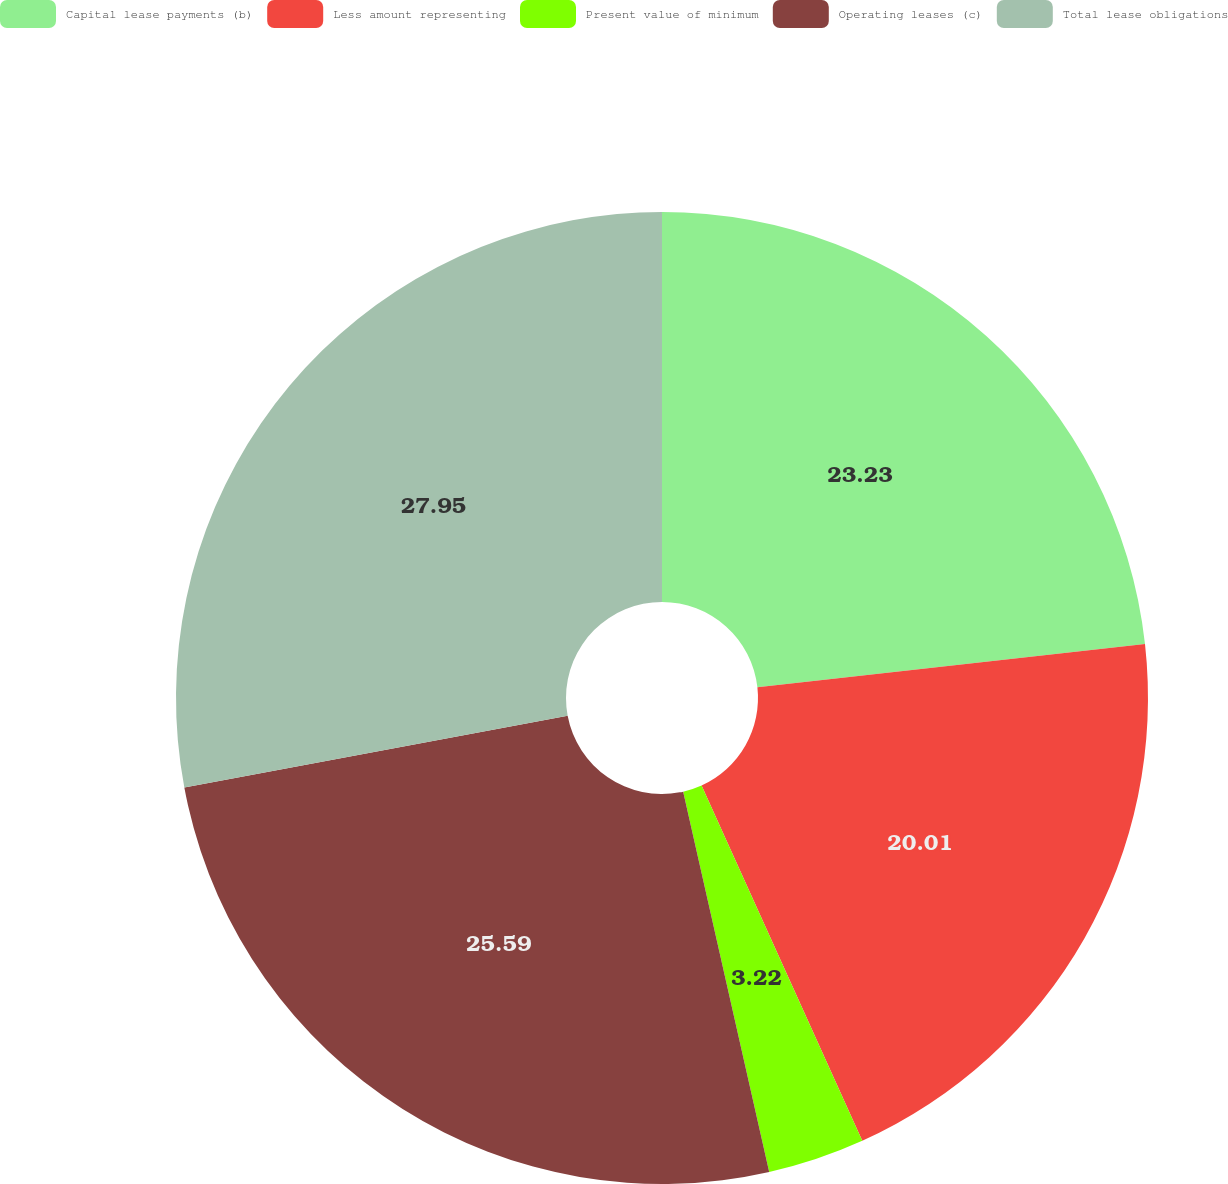<chart> <loc_0><loc_0><loc_500><loc_500><pie_chart><fcel>Capital lease payments (b)<fcel>Less amount representing<fcel>Present value of minimum<fcel>Operating leases (c)<fcel>Total lease obligations<nl><fcel>23.23%<fcel>20.01%<fcel>3.22%<fcel>25.59%<fcel>27.95%<nl></chart> 